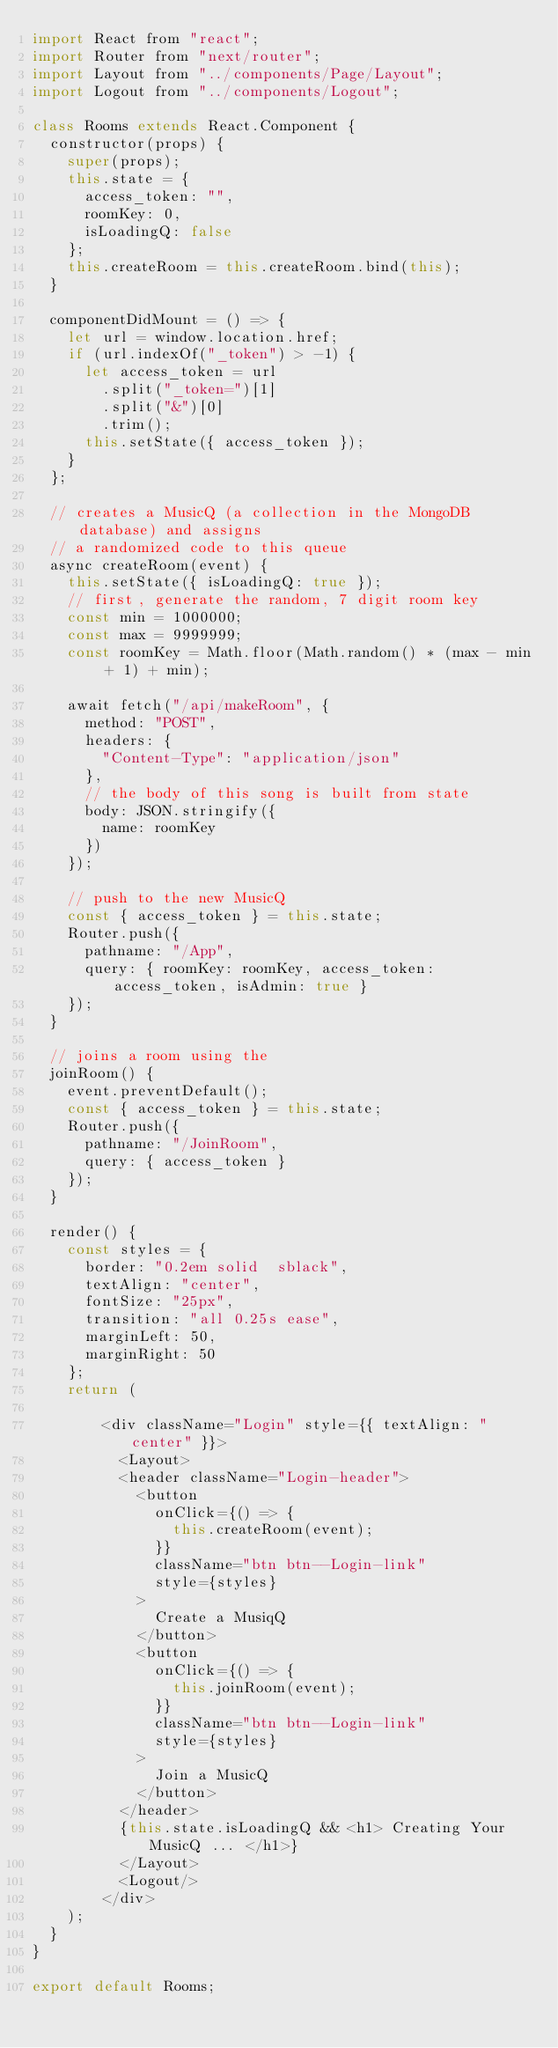Convert code to text. <code><loc_0><loc_0><loc_500><loc_500><_JavaScript_>import React from "react";
import Router from "next/router";
import Layout from "../components/Page/Layout";
import Logout from "../components/Logout";

class Rooms extends React.Component {
  constructor(props) {
    super(props);
    this.state = {
      access_token: "",
      roomKey: 0,
      isLoadingQ: false
    };
    this.createRoom = this.createRoom.bind(this);
  }

  componentDidMount = () => {
    let url = window.location.href;
    if (url.indexOf("_token") > -1) {
      let access_token = url
        .split("_token=")[1]
        .split("&")[0]
        .trim();
      this.setState({ access_token });
    }
  };

  // creates a MusicQ (a collection in the MongoDB database) and assigns
  // a randomized code to this queue
  async createRoom(event) {
    this.setState({ isLoadingQ: true });
    // first, generate the random, 7 digit room key
    const min = 1000000;
    const max = 9999999;
    const roomKey = Math.floor(Math.random() * (max - min + 1) + min);

    await fetch("/api/makeRoom", {
      method: "POST",
      headers: {
        "Content-Type": "application/json"
      },
      // the body of this song is built from state
      body: JSON.stringify({
        name: roomKey
      })
    });

    // push to the new MusicQ
    const { access_token } = this.state;
    Router.push({
      pathname: "/App",
      query: { roomKey: roomKey, access_token: access_token, isAdmin: true }
    });
  }

  // joins a room using the
  joinRoom() {
    event.preventDefault();
    const { access_token } = this.state;
    Router.push({
      pathname: "/JoinRoom",
      query: { access_token }
    });
  }

  render() {
    const styles = {
      border: "0.2em solid  sblack",
      textAlign: "center",
      fontSize: "25px",
      transition: "all 0.25s ease",
      marginLeft: 50,
      marginRight: 50
    };
    return (
      
        <div className="Login" style={{ textAlign: "center" }}>
          <Layout>
          <header className="Login-header">
            <button
              onClick={() => {
                this.createRoom(event);
              }}
              className="btn btn--Login-link"
              style={styles}
            >
              Create a MusiqQ
            </button>
            <button
              onClick={() => {
                this.joinRoom(event);
              }}
              className="btn btn--Login-link"
              style={styles}
            >
              Join a MusicQ
            </button>
          </header>
          {this.state.isLoadingQ && <h1> Creating Your MusicQ ... </h1>}
          </Layout>
          <Logout/>
        </div>
    );
  }
}

export default Rooms;
</code> 